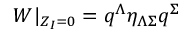Convert formula to latex. <formula><loc_0><loc_0><loc_500><loc_500>W | _ { Z _ { I } = 0 } = q ^ { \Lambda } \eta _ { \Lambda \Sigma } q ^ { \Sigma }</formula> 